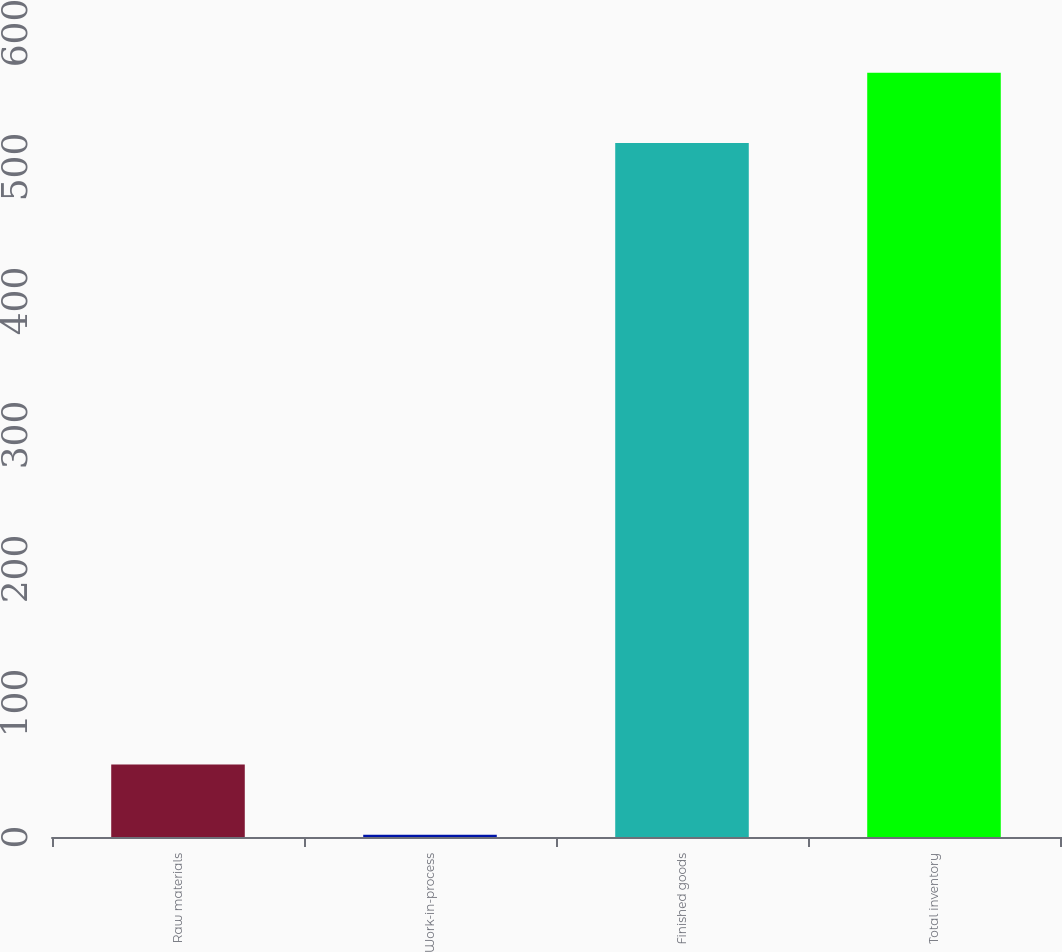Convert chart to OTSL. <chart><loc_0><loc_0><loc_500><loc_500><bar_chart><fcel>Raw materials<fcel>Work-in-process<fcel>Finished goods<fcel>Total inventory<nl><fcel>54.04<fcel>1.7<fcel>518<fcel>570.34<nl></chart> 